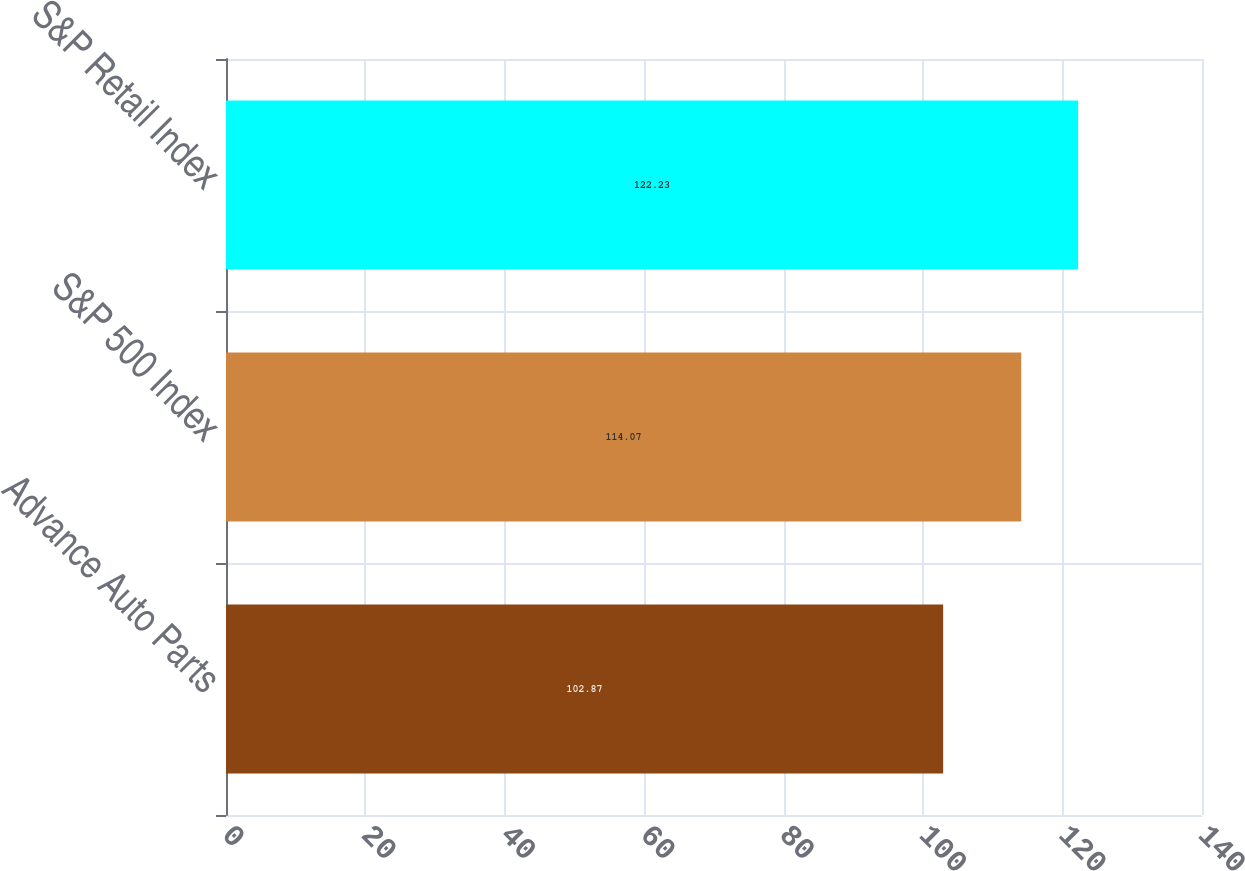<chart> <loc_0><loc_0><loc_500><loc_500><bar_chart><fcel>Advance Auto Parts<fcel>S&P 500 Index<fcel>S&P Retail Index<nl><fcel>102.87<fcel>114.07<fcel>122.23<nl></chart> 